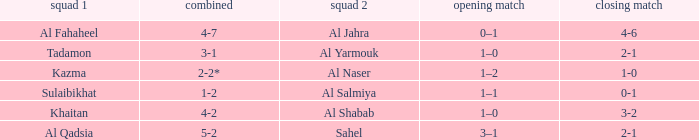What is the 1st leg of the Al Fahaheel Team 1? 0–1. 